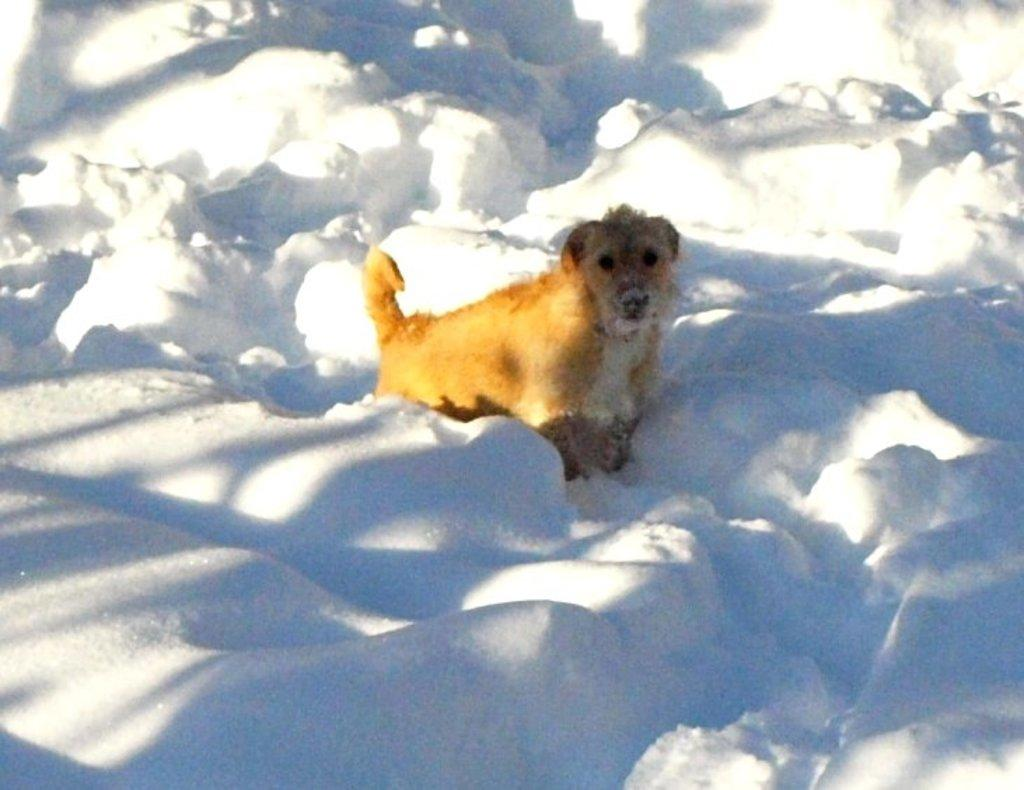What type of animal is in the image? There is a dog in the image. What color is the dog? The dog is brown in color. What is the dog doing in the image? The dog is looking at the camera. What can be seen in the background of the image? There is ice visible in the background of the image. What type of basin is the dog using in the image? There is no basin present in the image; it features a dog looking at the camera with ice visible in the background. How does the laborer interact with the dog in the image? There is no laborer present in the image; it only features a dog looking at the camera with ice visible in the background. 